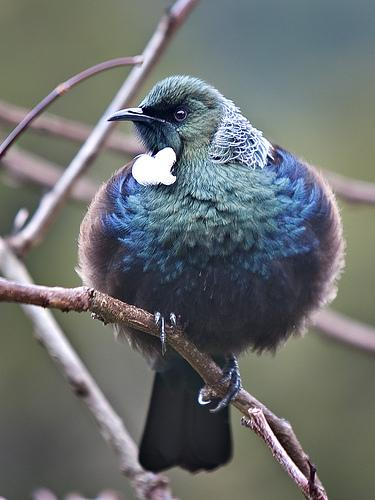Question: what type of animal is this?
Choices:
A. Dog.
B. A bird.
C. Cat.
D. Fish.
Answer with the letter. Answer: B Question: where is the bird looking?
Choices:
A. To the right.
B. To the left.
C. Up.
D. Down.
Answer with the letter. Answer: A Question: how many claws does the bird have?
Choices:
A. 4.
B. 3.
C. 6.
D. 2.
Answer with the letter. Answer: C 